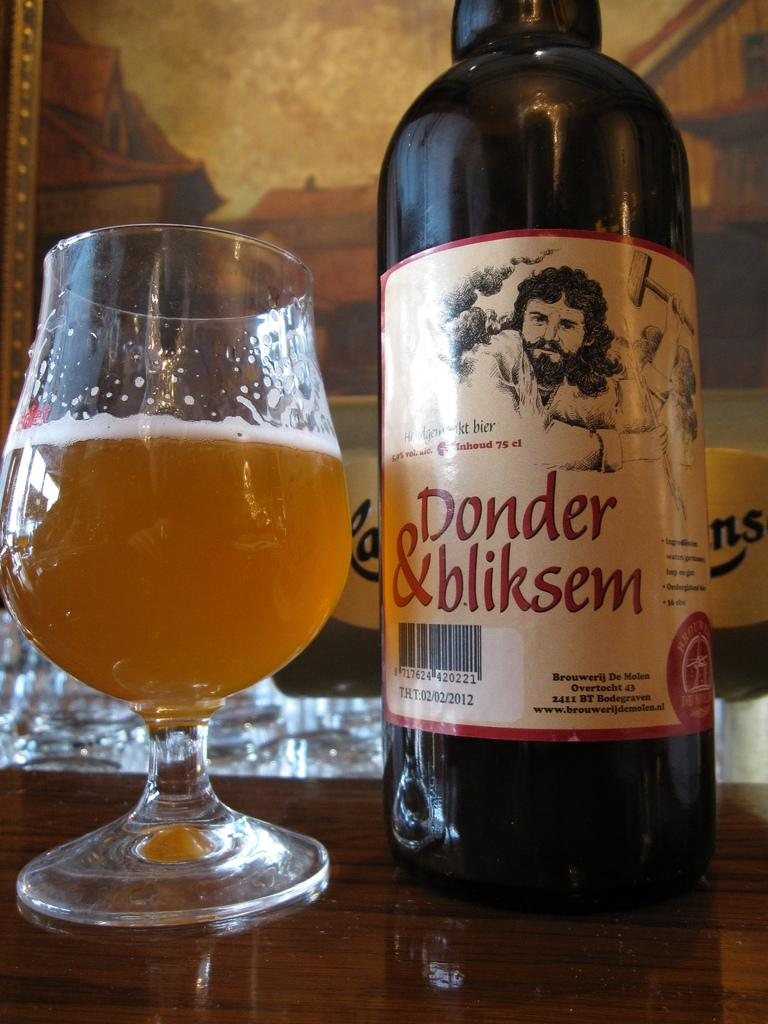<image>
Present a compact description of the photo's key features. A half full snifter next to a bottle of Donder & bliksen beer. 